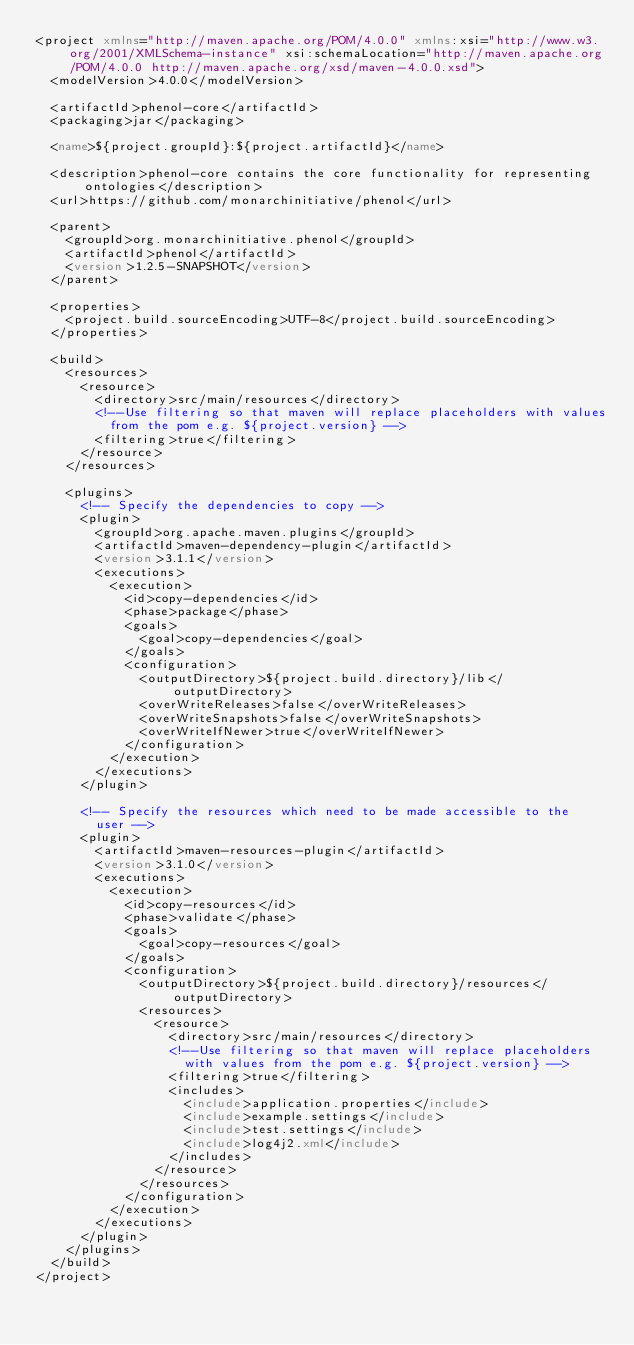<code> <loc_0><loc_0><loc_500><loc_500><_XML_><project xmlns="http://maven.apache.org/POM/4.0.0" xmlns:xsi="http://www.w3.org/2001/XMLSchema-instance" xsi:schemaLocation="http://maven.apache.org/POM/4.0.0 http://maven.apache.org/xsd/maven-4.0.0.xsd">
  <modelVersion>4.0.0</modelVersion>

  <artifactId>phenol-core</artifactId>
  <packaging>jar</packaging>

  <name>${project.groupId}:${project.artifactId}</name>

  <description>phenol-core contains the core functionality for representing ontologies</description>
  <url>https://github.com/monarchinitiative/phenol</url>

  <parent>
    <groupId>org.monarchinitiative.phenol</groupId>
    <artifactId>phenol</artifactId>
    <version>1.2.5-SNAPSHOT</version>
  </parent>

  <properties>
    <project.build.sourceEncoding>UTF-8</project.build.sourceEncoding>
  </properties>

  <build>
    <resources>
      <resource>
        <directory>src/main/resources</directory>
        <!--Use filtering so that maven will replace placeholders with values
          from the pom e.g. ${project.version} -->
        <filtering>true</filtering>
      </resource>
    </resources>

    <plugins>
      <!-- Specify the dependencies to copy -->
      <plugin>
        <groupId>org.apache.maven.plugins</groupId>
        <artifactId>maven-dependency-plugin</artifactId>
        <version>3.1.1</version>
        <executions>
          <execution>
            <id>copy-dependencies</id>
            <phase>package</phase>
            <goals>
              <goal>copy-dependencies</goal>
            </goals>
            <configuration>
              <outputDirectory>${project.build.directory}/lib</outputDirectory>
              <overWriteReleases>false</overWriteReleases>
              <overWriteSnapshots>false</overWriteSnapshots>
              <overWriteIfNewer>true</overWriteIfNewer>
            </configuration>
          </execution>
        </executions>
      </plugin>

      <!-- Specify the resources which need to be made accessible to the
        user -->
      <plugin>
        <artifactId>maven-resources-plugin</artifactId>
        <version>3.1.0</version>
        <executions>
          <execution>
            <id>copy-resources</id>
            <phase>validate</phase>
            <goals>
              <goal>copy-resources</goal>
            </goals>
            <configuration>
              <outputDirectory>${project.build.directory}/resources</outputDirectory>
              <resources>
                <resource>
                  <directory>src/main/resources</directory>
                  <!--Use filtering so that maven will replace placeholders
                    with values from the pom e.g. ${project.version} -->
                  <filtering>true</filtering>
                  <includes>
                    <include>application.properties</include>
                    <include>example.settings</include>
                    <include>test.settings</include>
                    <include>log4j2.xml</include>
                  </includes>
                </resource>
              </resources>
            </configuration>
          </execution>
        </executions>
      </plugin>
    </plugins>
  </build>
</project>
</code> 